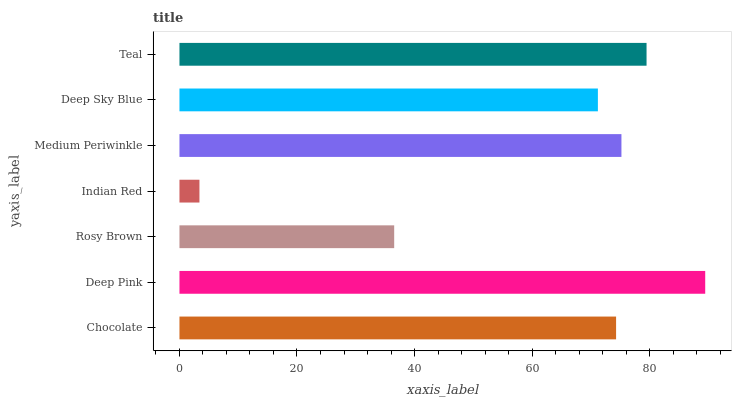Is Indian Red the minimum?
Answer yes or no. Yes. Is Deep Pink the maximum?
Answer yes or no. Yes. Is Rosy Brown the minimum?
Answer yes or no. No. Is Rosy Brown the maximum?
Answer yes or no. No. Is Deep Pink greater than Rosy Brown?
Answer yes or no. Yes. Is Rosy Brown less than Deep Pink?
Answer yes or no. Yes. Is Rosy Brown greater than Deep Pink?
Answer yes or no. No. Is Deep Pink less than Rosy Brown?
Answer yes or no. No. Is Chocolate the high median?
Answer yes or no. Yes. Is Chocolate the low median?
Answer yes or no. Yes. Is Medium Periwinkle the high median?
Answer yes or no. No. Is Teal the low median?
Answer yes or no. No. 